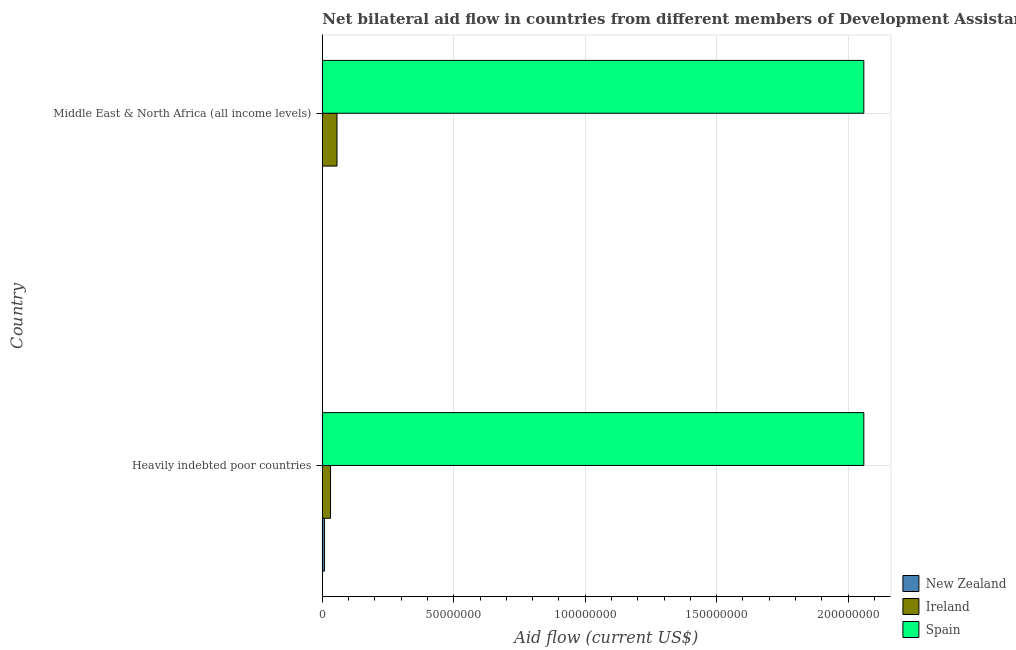How many different coloured bars are there?
Provide a short and direct response. 3. How many groups of bars are there?
Provide a succinct answer. 2. Are the number of bars per tick equal to the number of legend labels?
Your answer should be compact. Yes. Are the number of bars on each tick of the Y-axis equal?
Your answer should be compact. Yes. How many bars are there on the 1st tick from the top?
Give a very brief answer. 3. What is the label of the 1st group of bars from the top?
Offer a very short reply. Middle East & North Africa (all income levels). In how many cases, is the number of bars for a given country not equal to the number of legend labels?
Your response must be concise. 0. What is the amount of aid provided by new zealand in Middle East & North Africa (all income levels)?
Make the answer very short. 3.00e+04. Across all countries, what is the maximum amount of aid provided by spain?
Your answer should be compact. 2.06e+08. Across all countries, what is the minimum amount of aid provided by ireland?
Your answer should be compact. 3.12e+06. In which country was the amount of aid provided by spain maximum?
Your answer should be very brief. Heavily indebted poor countries. In which country was the amount of aid provided by new zealand minimum?
Offer a very short reply. Middle East & North Africa (all income levels). What is the total amount of aid provided by new zealand in the graph?
Make the answer very short. 8.30e+05. What is the difference between the amount of aid provided by ireland in Heavily indebted poor countries and that in Middle East & North Africa (all income levels)?
Your answer should be very brief. -2.46e+06. What is the difference between the amount of aid provided by ireland in Heavily indebted poor countries and the amount of aid provided by spain in Middle East & North Africa (all income levels)?
Your answer should be very brief. -2.03e+08. What is the average amount of aid provided by ireland per country?
Offer a very short reply. 4.35e+06. What is the difference between the amount of aid provided by new zealand and amount of aid provided by spain in Heavily indebted poor countries?
Your response must be concise. -2.05e+08. What is the ratio of the amount of aid provided by new zealand in Heavily indebted poor countries to that in Middle East & North Africa (all income levels)?
Your response must be concise. 26.67. In how many countries, is the amount of aid provided by ireland greater than the average amount of aid provided by ireland taken over all countries?
Your response must be concise. 1. What does the 3rd bar from the top in Heavily indebted poor countries represents?
Your response must be concise. New Zealand. What does the 2nd bar from the bottom in Heavily indebted poor countries represents?
Give a very brief answer. Ireland. How many bars are there?
Give a very brief answer. 6. Are all the bars in the graph horizontal?
Your response must be concise. Yes. How many countries are there in the graph?
Provide a short and direct response. 2. Are the values on the major ticks of X-axis written in scientific E-notation?
Give a very brief answer. No. Does the graph contain grids?
Make the answer very short. Yes. Where does the legend appear in the graph?
Offer a terse response. Bottom right. How many legend labels are there?
Provide a succinct answer. 3. What is the title of the graph?
Your answer should be compact. Net bilateral aid flow in countries from different members of Development Assistance Committee. Does "Ages 65 and above" appear as one of the legend labels in the graph?
Your answer should be compact. No. What is the label or title of the Y-axis?
Give a very brief answer. Country. What is the Aid flow (current US$) of Ireland in Heavily indebted poor countries?
Offer a very short reply. 3.12e+06. What is the Aid flow (current US$) of Spain in Heavily indebted poor countries?
Your answer should be very brief. 2.06e+08. What is the Aid flow (current US$) in New Zealand in Middle East & North Africa (all income levels)?
Keep it short and to the point. 3.00e+04. What is the Aid flow (current US$) of Ireland in Middle East & North Africa (all income levels)?
Make the answer very short. 5.58e+06. What is the Aid flow (current US$) in Spain in Middle East & North Africa (all income levels)?
Provide a short and direct response. 2.06e+08. Across all countries, what is the maximum Aid flow (current US$) of New Zealand?
Your answer should be compact. 8.00e+05. Across all countries, what is the maximum Aid flow (current US$) in Ireland?
Offer a terse response. 5.58e+06. Across all countries, what is the maximum Aid flow (current US$) in Spain?
Offer a very short reply. 2.06e+08. Across all countries, what is the minimum Aid flow (current US$) in Ireland?
Your answer should be very brief. 3.12e+06. Across all countries, what is the minimum Aid flow (current US$) in Spain?
Offer a very short reply. 2.06e+08. What is the total Aid flow (current US$) of New Zealand in the graph?
Give a very brief answer. 8.30e+05. What is the total Aid flow (current US$) of Ireland in the graph?
Your answer should be compact. 8.70e+06. What is the total Aid flow (current US$) in Spain in the graph?
Offer a terse response. 4.12e+08. What is the difference between the Aid flow (current US$) in New Zealand in Heavily indebted poor countries and that in Middle East & North Africa (all income levels)?
Make the answer very short. 7.70e+05. What is the difference between the Aid flow (current US$) in Ireland in Heavily indebted poor countries and that in Middle East & North Africa (all income levels)?
Keep it short and to the point. -2.46e+06. What is the difference between the Aid flow (current US$) of Spain in Heavily indebted poor countries and that in Middle East & North Africa (all income levels)?
Keep it short and to the point. 0. What is the difference between the Aid flow (current US$) in New Zealand in Heavily indebted poor countries and the Aid flow (current US$) in Ireland in Middle East & North Africa (all income levels)?
Offer a very short reply. -4.78e+06. What is the difference between the Aid flow (current US$) in New Zealand in Heavily indebted poor countries and the Aid flow (current US$) in Spain in Middle East & North Africa (all income levels)?
Keep it short and to the point. -2.05e+08. What is the difference between the Aid flow (current US$) of Ireland in Heavily indebted poor countries and the Aid flow (current US$) of Spain in Middle East & North Africa (all income levels)?
Keep it short and to the point. -2.03e+08. What is the average Aid flow (current US$) of New Zealand per country?
Keep it short and to the point. 4.15e+05. What is the average Aid flow (current US$) in Ireland per country?
Your answer should be very brief. 4.35e+06. What is the average Aid flow (current US$) in Spain per country?
Provide a succinct answer. 2.06e+08. What is the difference between the Aid flow (current US$) in New Zealand and Aid flow (current US$) in Ireland in Heavily indebted poor countries?
Keep it short and to the point. -2.32e+06. What is the difference between the Aid flow (current US$) of New Zealand and Aid flow (current US$) of Spain in Heavily indebted poor countries?
Offer a terse response. -2.05e+08. What is the difference between the Aid flow (current US$) in Ireland and Aid flow (current US$) in Spain in Heavily indebted poor countries?
Provide a short and direct response. -2.03e+08. What is the difference between the Aid flow (current US$) of New Zealand and Aid flow (current US$) of Ireland in Middle East & North Africa (all income levels)?
Provide a succinct answer. -5.55e+06. What is the difference between the Aid flow (current US$) of New Zealand and Aid flow (current US$) of Spain in Middle East & North Africa (all income levels)?
Give a very brief answer. -2.06e+08. What is the difference between the Aid flow (current US$) in Ireland and Aid flow (current US$) in Spain in Middle East & North Africa (all income levels)?
Keep it short and to the point. -2.00e+08. What is the ratio of the Aid flow (current US$) in New Zealand in Heavily indebted poor countries to that in Middle East & North Africa (all income levels)?
Your response must be concise. 26.67. What is the ratio of the Aid flow (current US$) in Ireland in Heavily indebted poor countries to that in Middle East & North Africa (all income levels)?
Make the answer very short. 0.56. What is the ratio of the Aid flow (current US$) of Spain in Heavily indebted poor countries to that in Middle East & North Africa (all income levels)?
Your response must be concise. 1. What is the difference between the highest and the second highest Aid flow (current US$) in New Zealand?
Make the answer very short. 7.70e+05. What is the difference between the highest and the second highest Aid flow (current US$) of Ireland?
Provide a succinct answer. 2.46e+06. What is the difference between the highest and the lowest Aid flow (current US$) of New Zealand?
Keep it short and to the point. 7.70e+05. What is the difference between the highest and the lowest Aid flow (current US$) in Ireland?
Give a very brief answer. 2.46e+06. 